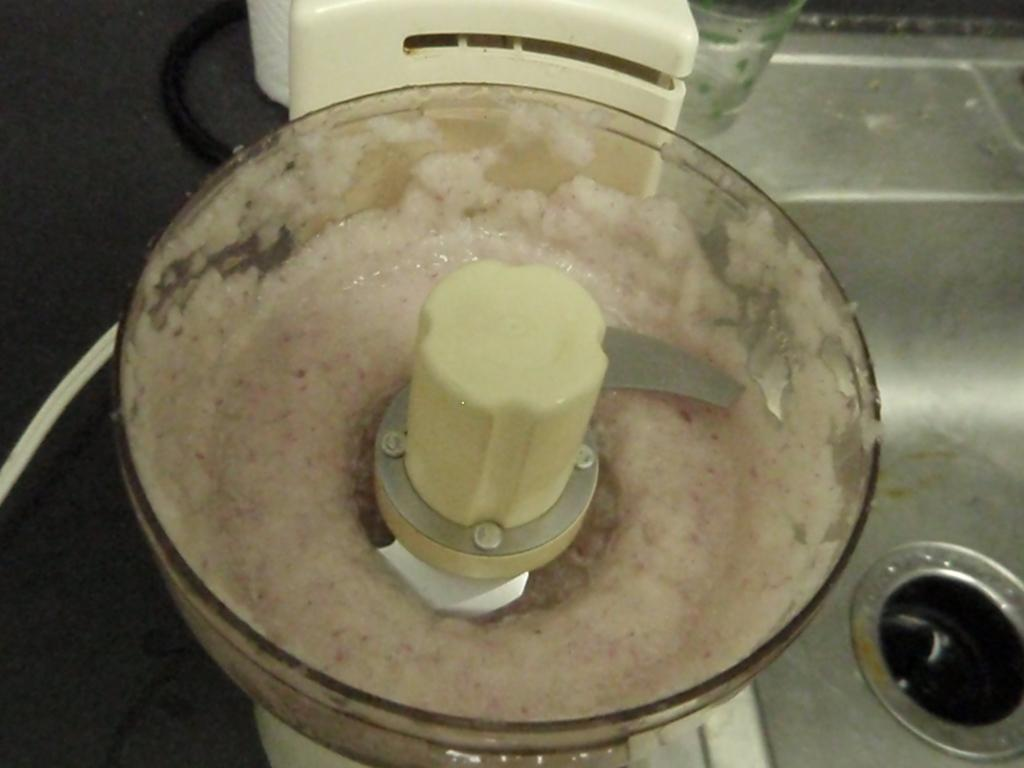What appliance is visible in the image? There is a mixer grinder in the image. What is inside the mixer grinder? There is an item inside the mixer grinder. Can you describe any specific features of the mixer grinder? There is a hole in the right corner of the mixer grinder. How does the mixer grinder affect the slope of the nearby hill in the image? There is no hill or slope present in the image, so the mixer grinder does not affect any slope. 